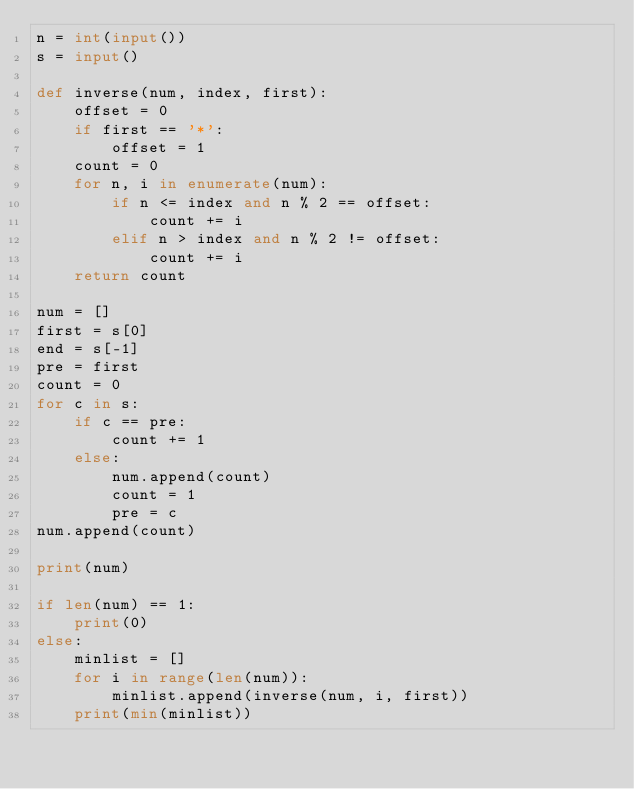Convert code to text. <code><loc_0><loc_0><loc_500><loc_500><_Python_>n = int(input())
s = input()

def inverse(num, index, first):
    offset = 0
    if first == '*':
        offset = 1
    count = 0
    for n, i in enumerate(num):
        if n <= index and n % 2 == offset:
            count += i
        elif n > index and n % 2 != offset:
            count += i
    return count

num = []
first = s[0]
end = s[-1]
pre = first
count = 0
for c in s:
    if c == pre:
        count += 1
    else:
        num.append(count)
        count = 1
        pre = c
num.append(count)

print(num)

if len(num) == 1:
    print(0)
else:
    minlist = []
    for i in range(len(num)):
        minlist.append(inverse(num, i, first))
    print(min(minlist))

</code> 